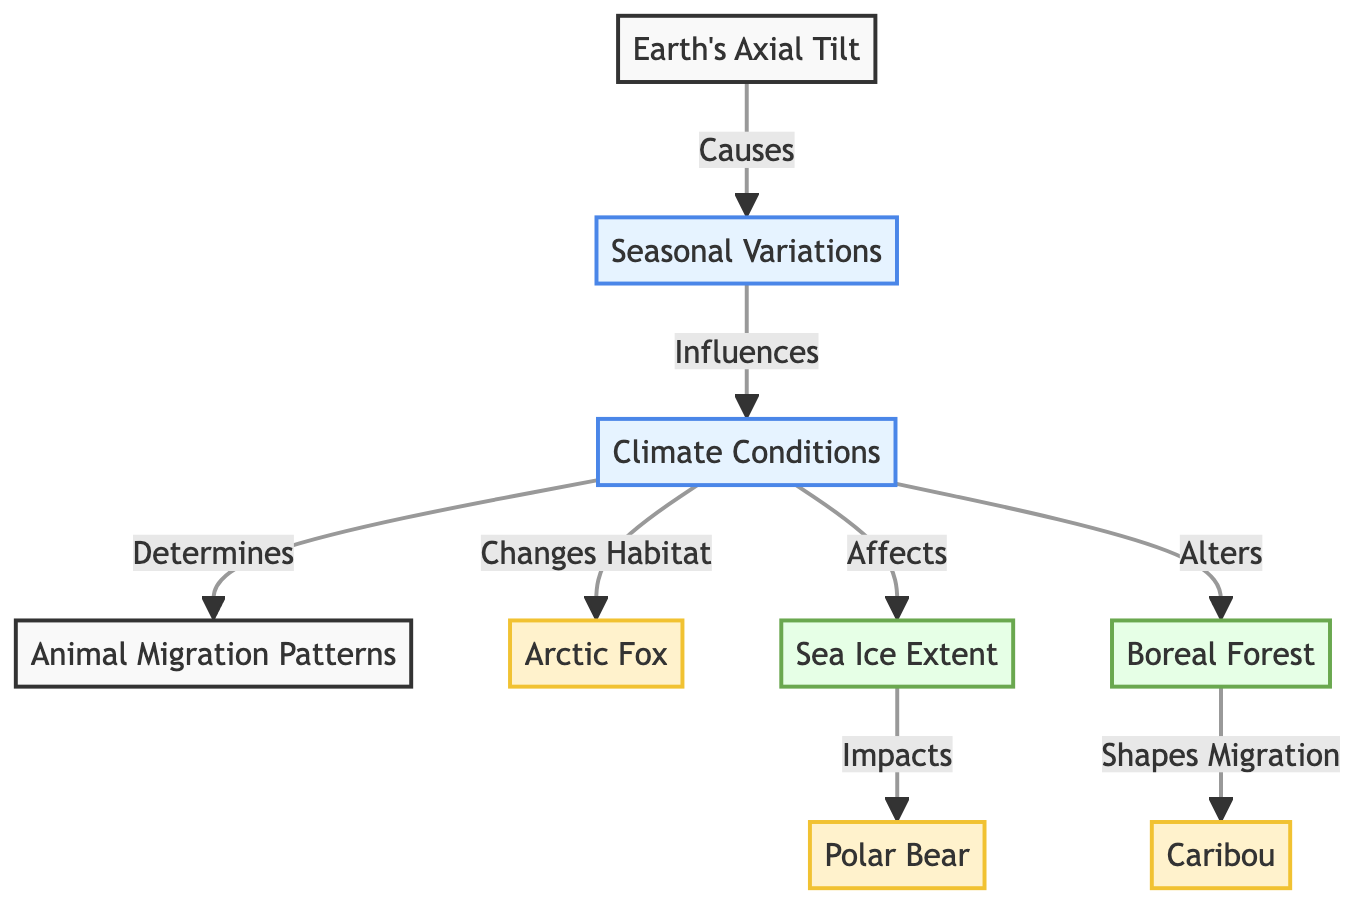What is the central factor influencing seasonal variations? The diagram shows that Earth's axial tilt causes seasonal variations. This effect leads to changes in climate conditions, which are depicted as connected arrows originating from the axial tilt node.
Answer: Earth's Axial Tilt How many animal species are represented in the diagram? The diagram features three animal species: Caribou, Arctic Fox, and Polar Bear. Each species is represented as a separate node in the diagram.
Answer: Three What environmental aspect does climate conditions impact? The diagram indicates that climate conditions affect sea ice extent and boreal forest. Both aspects are shown as nodes that are connected to climate conditions via directed arrows.
Answer: Sea Ice Extent and Boreal Forest Which species is directly impacted by changes in sea ice extent? According to the diagram, climate conditions influence sea ice extent, which in turn impacts Polar Bear. The directed arrows show this causal pathway clearly.
Answer: Polar Bear How do climate conditions determine migration patterns? The diagram indicates that climate conditions influence migration patterns directly. This is stated as an arrow leading from climate conditions to the migration patterns node, illustrating the relationship.
Answer: Climate Conditions What are the two main environmental factors affected by climate conditions? The diagram shows that climate conditions alter boreal forest and affect sea ice extent. These connections are visually established through directed arrows pointing to these environmental aspects.
Answer: Boreal Forest and Sea Ice Extent Which animal species' migration is shaped by boreal forest? The diagram suggests that the caribou migration is shaped by the boreal forest, as indicated by the directed arrow connecting these two nodes.
Answer: Caribou Determine the relationship between climate conditions and arctic fox habitat. The relationship is established in the diagram by stating that climate conditions change habitat for the arctic fox, which is visually represented by an arrow going from climate conditions to arctic fox.
Answer: Changes Habitat What is the effect of axial tilt on climate conditions? The diagram illustrates that Earth's axial tilt causes seasonal variations, which subsequently influence climate conditions, showing a sequential relationship from axial tilt to climate conditions.
Answer: Causes Seasonal Variations 